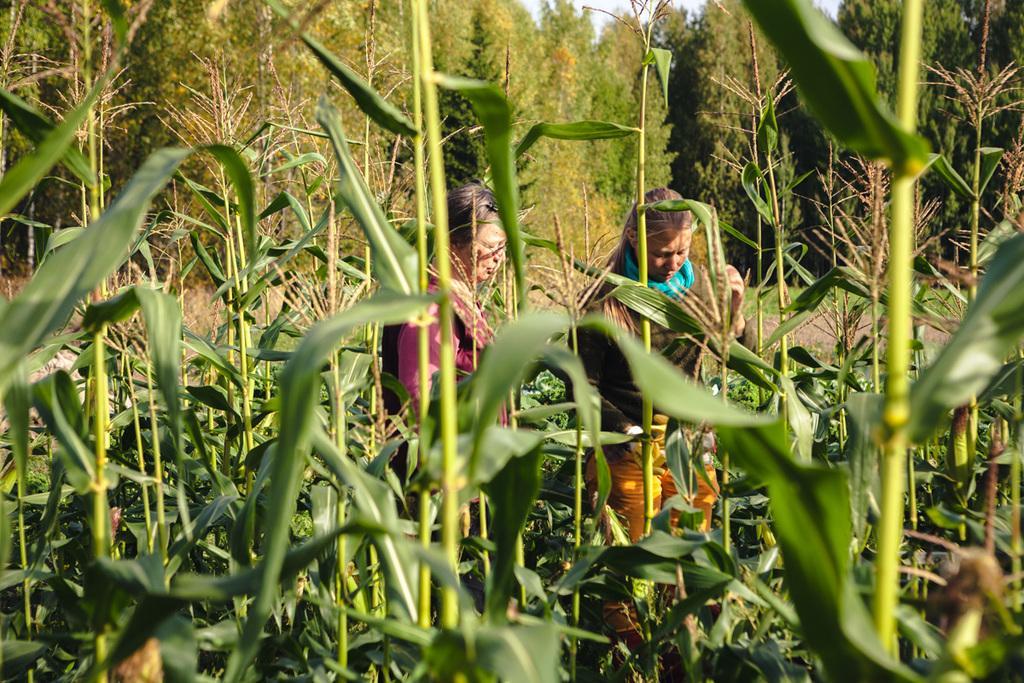Could you give a brief overview of what you see in this image? In this image we can see two women are standing on the ground. Here we can see the corn plants and in the background, we can see the trees. 